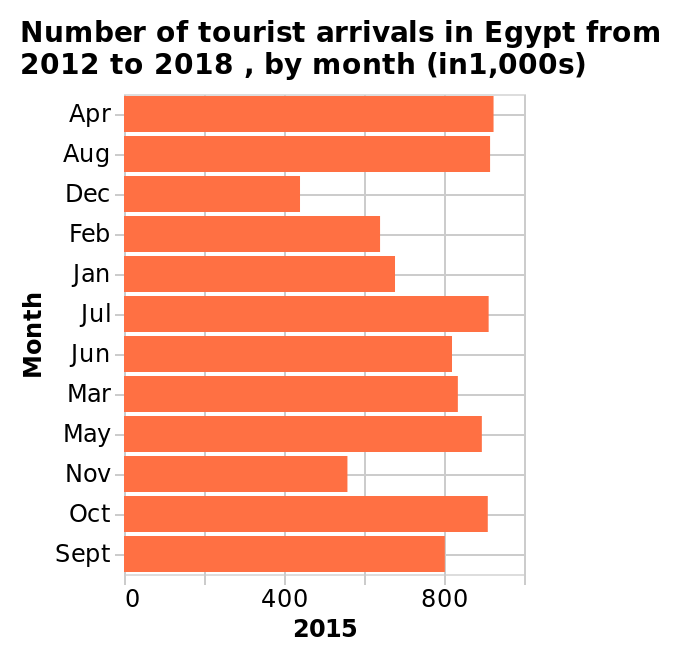<image>
please summary the statistics and relations of the chart The lowest months were all around the winter period of the year, from Nov-Feb of each year. The rest of the year was fairly consistent with tourist numbers, with fairly small fluctuations of around 10%. The peak months had twice as many tourists as the lowest months. Which months have the lowest number of visitors? The lowest number of visitors was in December and November. 